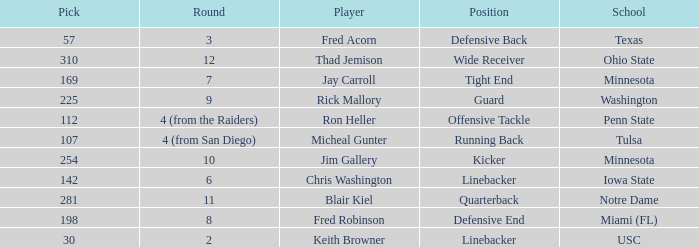What is the pick number of Penn State? 112.0. 